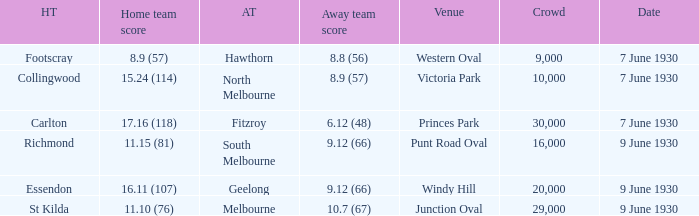Where did the away team score 8.9 (57)? Victoria Park. 